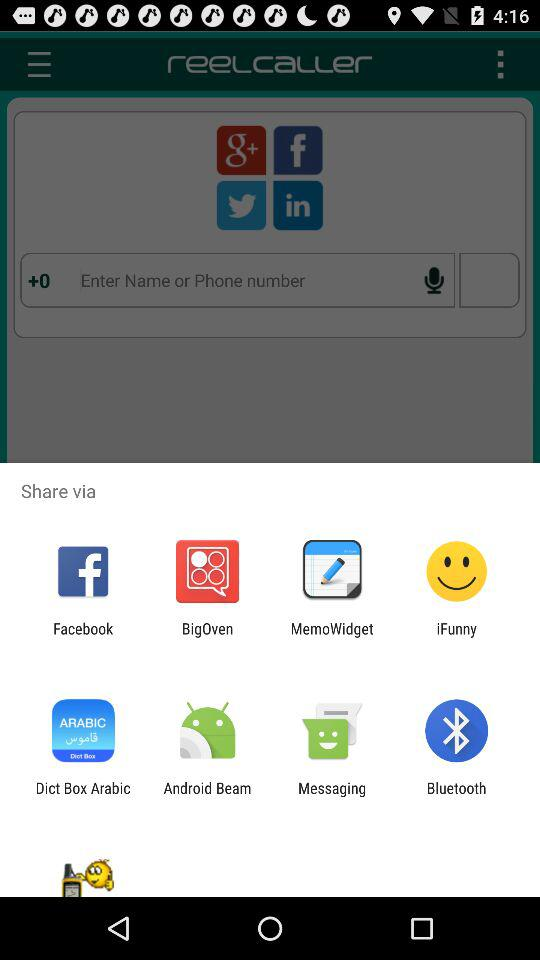Which options are given for sharing? The given options for sharing are "Facebook", "BigOven", "MemoWidget", "iFunny", "Dict Box Arabic", "Android Beam", "Messaging" and "Bluetooth". 